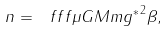<formula> <loc_0><loc_0><loc_500><loc_500>n = \ f f f { \mu G M m } { { g ^ { * } } ^ { 2 } \beta } ,</formula> 